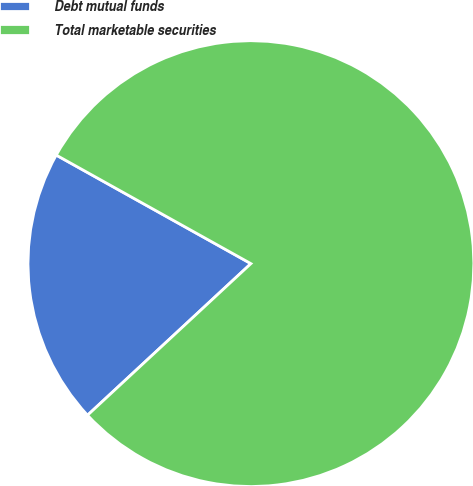<chart> <loc_0><loc_0><loc_500><loc_500><pie_chart><fcel>Debt mutual funds<fcel>Total marketable securities<nl><fcel>20.0%<fcel>80.0%<nl></chart> 